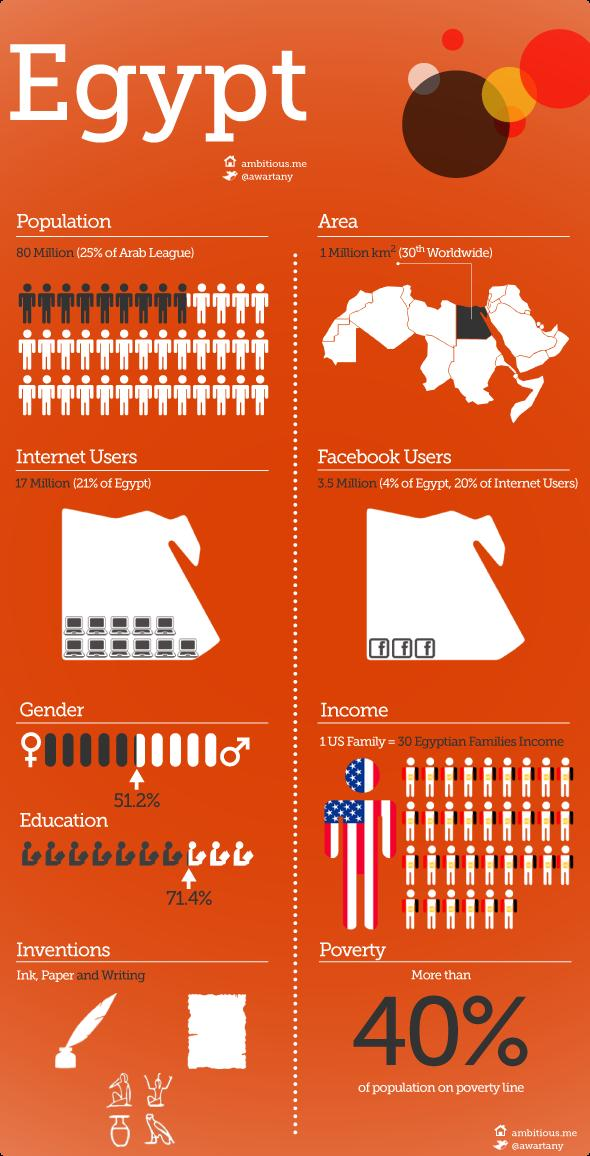Specify some key components in this picture. Approximately 3.5 million people in Egypt use Facebook. According to a recent survey, only 4% of the Egyptian population uses Facebook. The percentage of the Egyptian population that is male is 51.2%. In Egypt, 71.4% of the population is educated. According to data, 20% of Egypt's internet users rely on Facebook as their primary social media platform. 